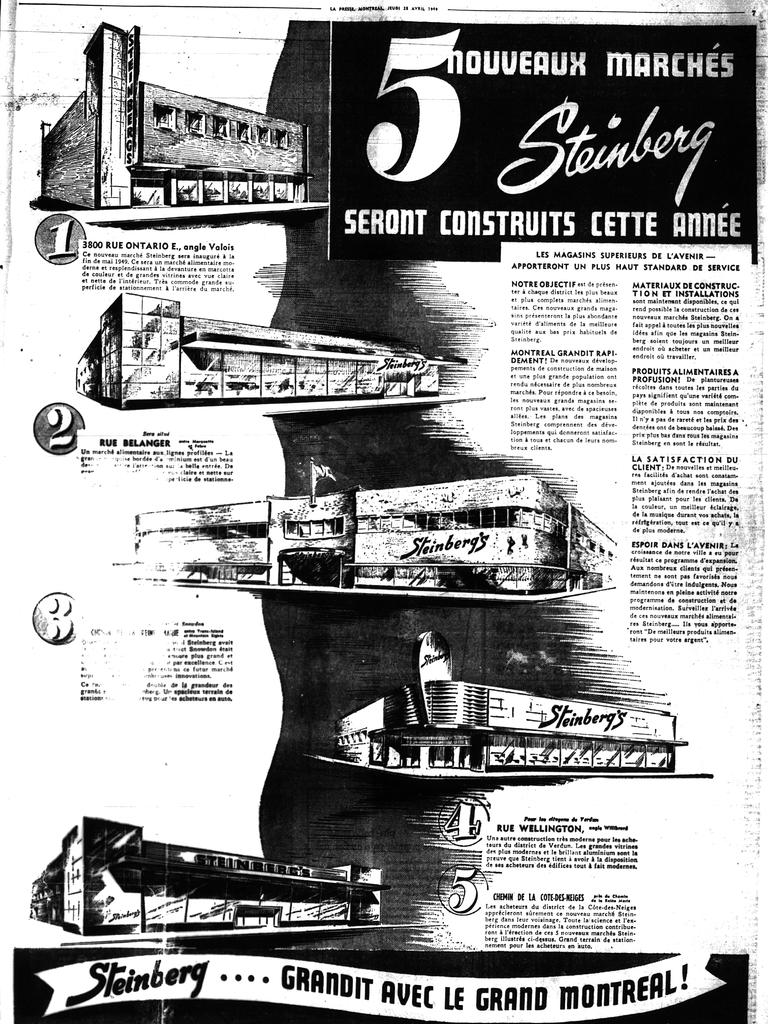Can you be able to read this article?
Give a very brief answer. No. What is the large number at the top?
Offer a terse response. 5. 